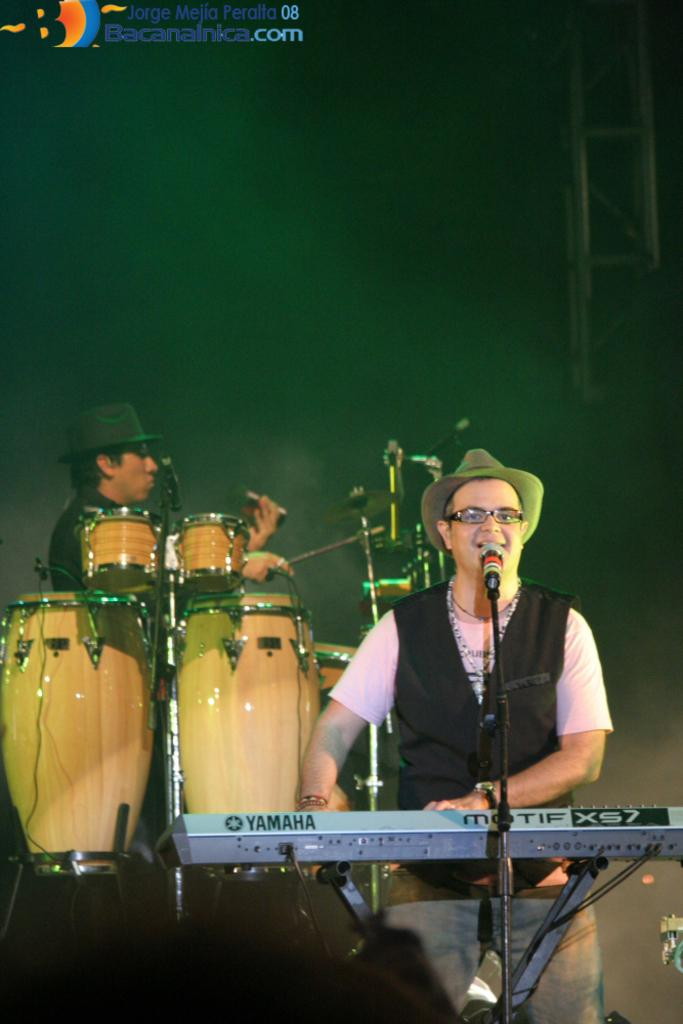What is the main activity of the person in the image? The person is playing a music keyboard and singing. Is there anyone else in the image? Yes, there is another person at the back in the image. What is the second person doing? The second person is playing drums. Can you see a snail moving across the music keyboard in the image? No, there is no snail present in the image. What type of wave can be seen in the image? There are no waves visible in the image; it features people playing musical instruments. 